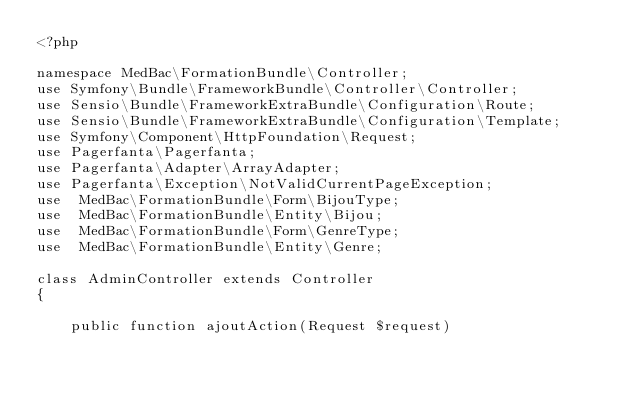<code> <loc_0><loc_0><loc_500><loc_500><_PHP_><?php

namespace MedBac\FormationBundle\Controller;
use Symfony\Bundle\FrameworkBundle\Controller\Controller;
use Sensio\Bundle\FrameworkExtraBundle\Configuration\Route;
use Sensio\Bundle\FrameworkExtraBundle\Configuration\Template;
use Symfony\Component\HttpFoundation\Request;
use Pagerfanta\Pagerfanta;
use Pagerfanta\Adapter\ArrayAdapter;
use Pagerfanta\Exception\NotValidCurrentPageException;
use  MedBac\FormationBundle\Form\BijouType;
use  MedBac\FormationBundle\Entity\Bijou;
use  MedBac\FormationBundle\Form\GenreType;
use  MedBac\FormationBundle\Entity\Genre;
 
class AdminController extends Controller
{
    
    public function ajoutAction(Request $request)</code> 